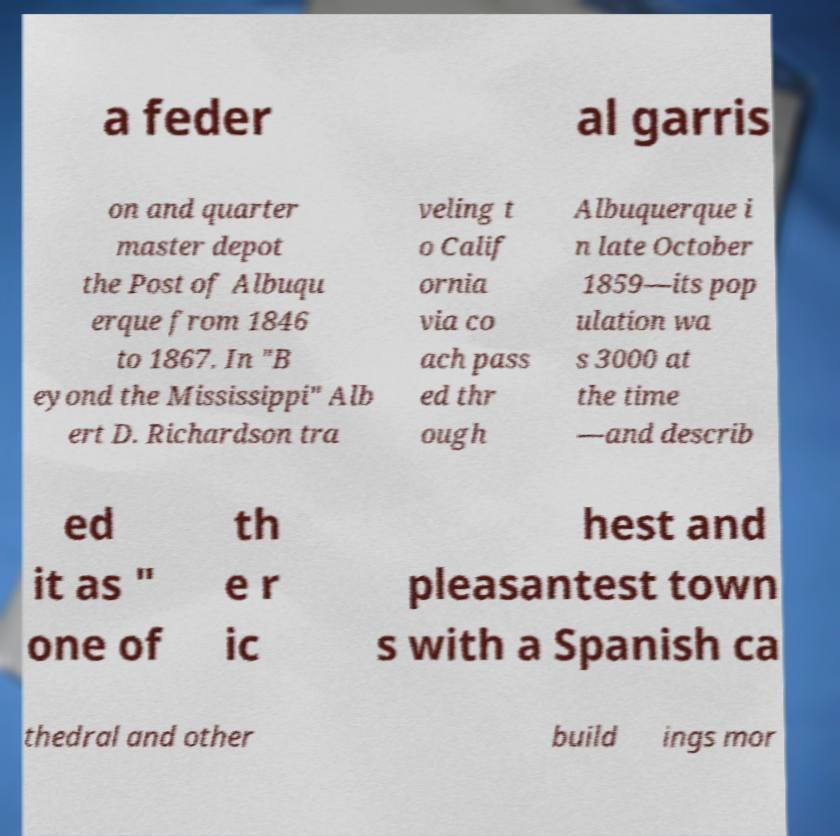What messages or text are displayed in this image? I need them in a readable, typed format. a feder al garris on and quarter master depot the Post of Albuqu erque from 1846 to 1867. In "B eyond the Mississippi" Alb ert D. Richardson tra veling t o Calif ornia via co ach pass ed thr ough Albuquerque i n late October 1859—its pop ulation wa s 3000 at the time —and describ ed it as " one of th e r ic hest and pleasantest town s with a Spanish ca thedral and other build ings mor 